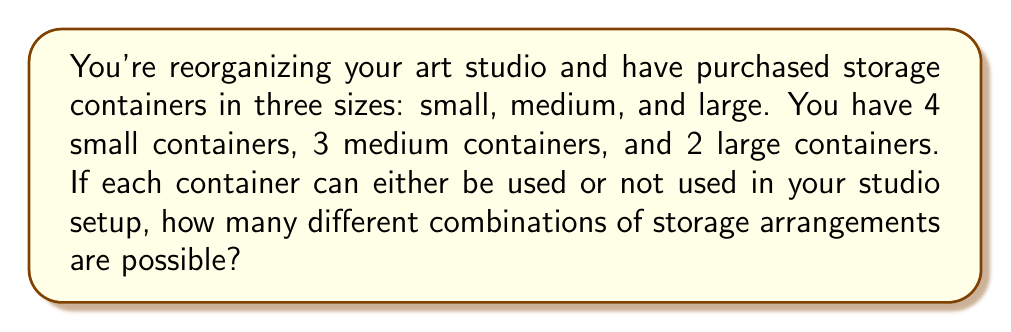Give your solution to this math problem. Let's approach this step-by-step:

1) For each container, we have two choices: use it or don't use it.

2) For small containers:
   - We have 4 containers, each with 2 choices
   - Total combinations for small containers: $2^4$

3) For medium containers:
   - We have 3 containers, each with 2 choices
   - Total combinations for medium containers: $2^3$

4) For large containers:
   - We have 2 containers, each with 2 choices
   - Total combinations for large containers: $2^2$

5) By the multiplication principle, to find the total number of combinations, we multiply the number of possibilities for each size:

   $$ \text{Total combinations} = 2^4 \times 2^3 \times 2^2 $$

6) Simplify:
   $$ 2^4 \times 2^3 \times 2^2 = 2^{4+3+2} = 2^9 = 512 $$

Therefore, there are 512 different possible combinations of storage arrangements.
Answer: 512 